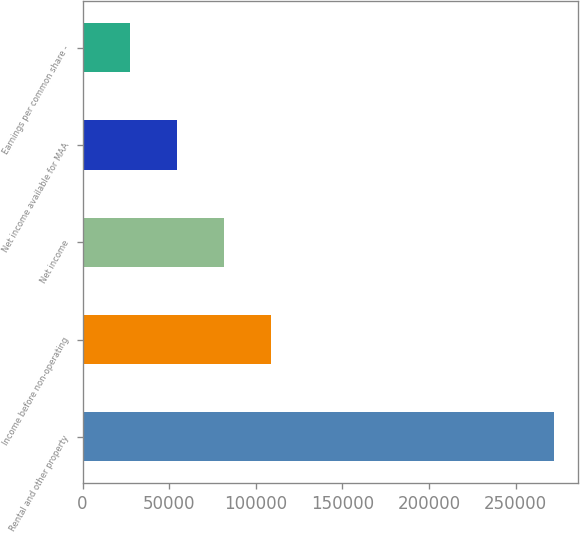Convert chart to OTSL. <chart><loc_0><loc_0><loc_500><loc_500><bar_chart><fcel>Rental and other property<fcel>Income before non-operating<fcel>Net income<fcel>Net income available for MAA<fcel>Earnings per common share -<nl><fcel>272236<fcel>108895<fcel>81671.2<fcel>54447.7<fcel>27224.1<nl></chart> 